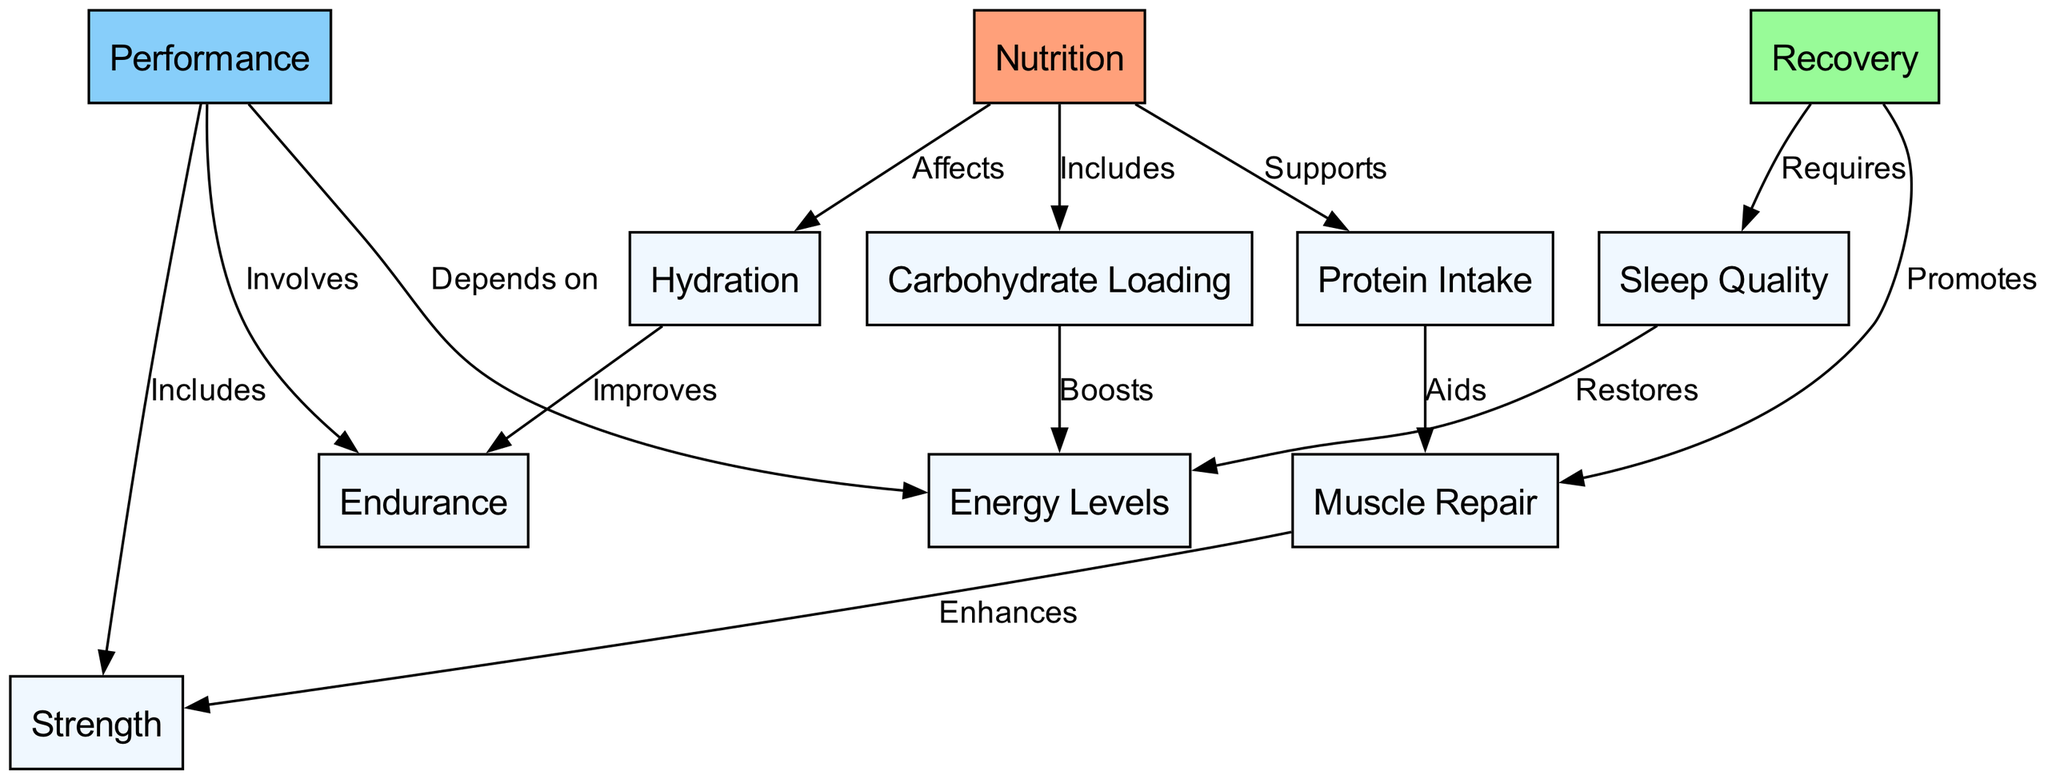What is the main topic of the concept map? The main topic is "Nutrition," which is the first node and serves as the root of the diagram.
Answer: Nutrition How many nodes are in the diagram? The diagram contains 10 unique nodes that include topics such as nutrition, recovery, performance, and their various components.
Answer: 10 What relationship does nutrition have with protein intake? The edge between nutrition and protein intake is labeled "Supports," indicating that nutrition plays a supportive role in protein intake.
Answer: Supports Which node directly promotes muscle repair? The node "Recovery" is directly linked to the node "Muscle Repair," with the edge labeled "Promotes," indicating that recovery promotes muscle repair.
Answer: Recovery How does carbohydrate loading affect energy levels? The edge from carbohydrate loading to energy levels is labeled "Boosts," which shows that carbohydrate loading enhances or increases energy levels.
Answer: Boosts What is required for recovery according to the diagram? The edge from recovery to sleep is labeled "Requires," indicating that sleep is a necessary component for recovery.
Answer: Sleep Which two aspects are included in performance? The nodes directly related to performance are "Strength" and "Endurance," as performance includes both aspects as reflected by the edges.
Answer: Strength and Endurance What improves endurance? The node "Hydration" is connected to "Endurance" with the label "Improves," indicating that proper hydration enhances endurance levels.
Answer: Hydration How does sleep influence energy levels? The edge from sleep to energy levels is labeled "Restores," meaning that sleep has a restorative effect on energy levels, crucial for performance.
Answer: Restores 